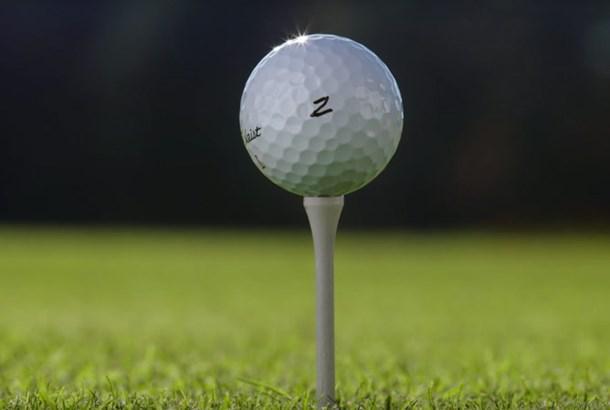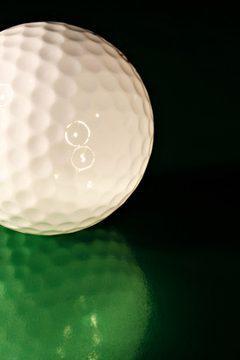The first image is the image on the left, the second image is the image on the right. Evaluate the accuracy of this statement regarding the images: "Right image shows one white golf ball perched on a tee.". Is it true? Answer yes or no. No. The first image is the image on the left, the second image is the image on the right. For the images shown, is this caption "The ball in the image on the right is sitting on a white tee." true? Answer yes or no. No. 